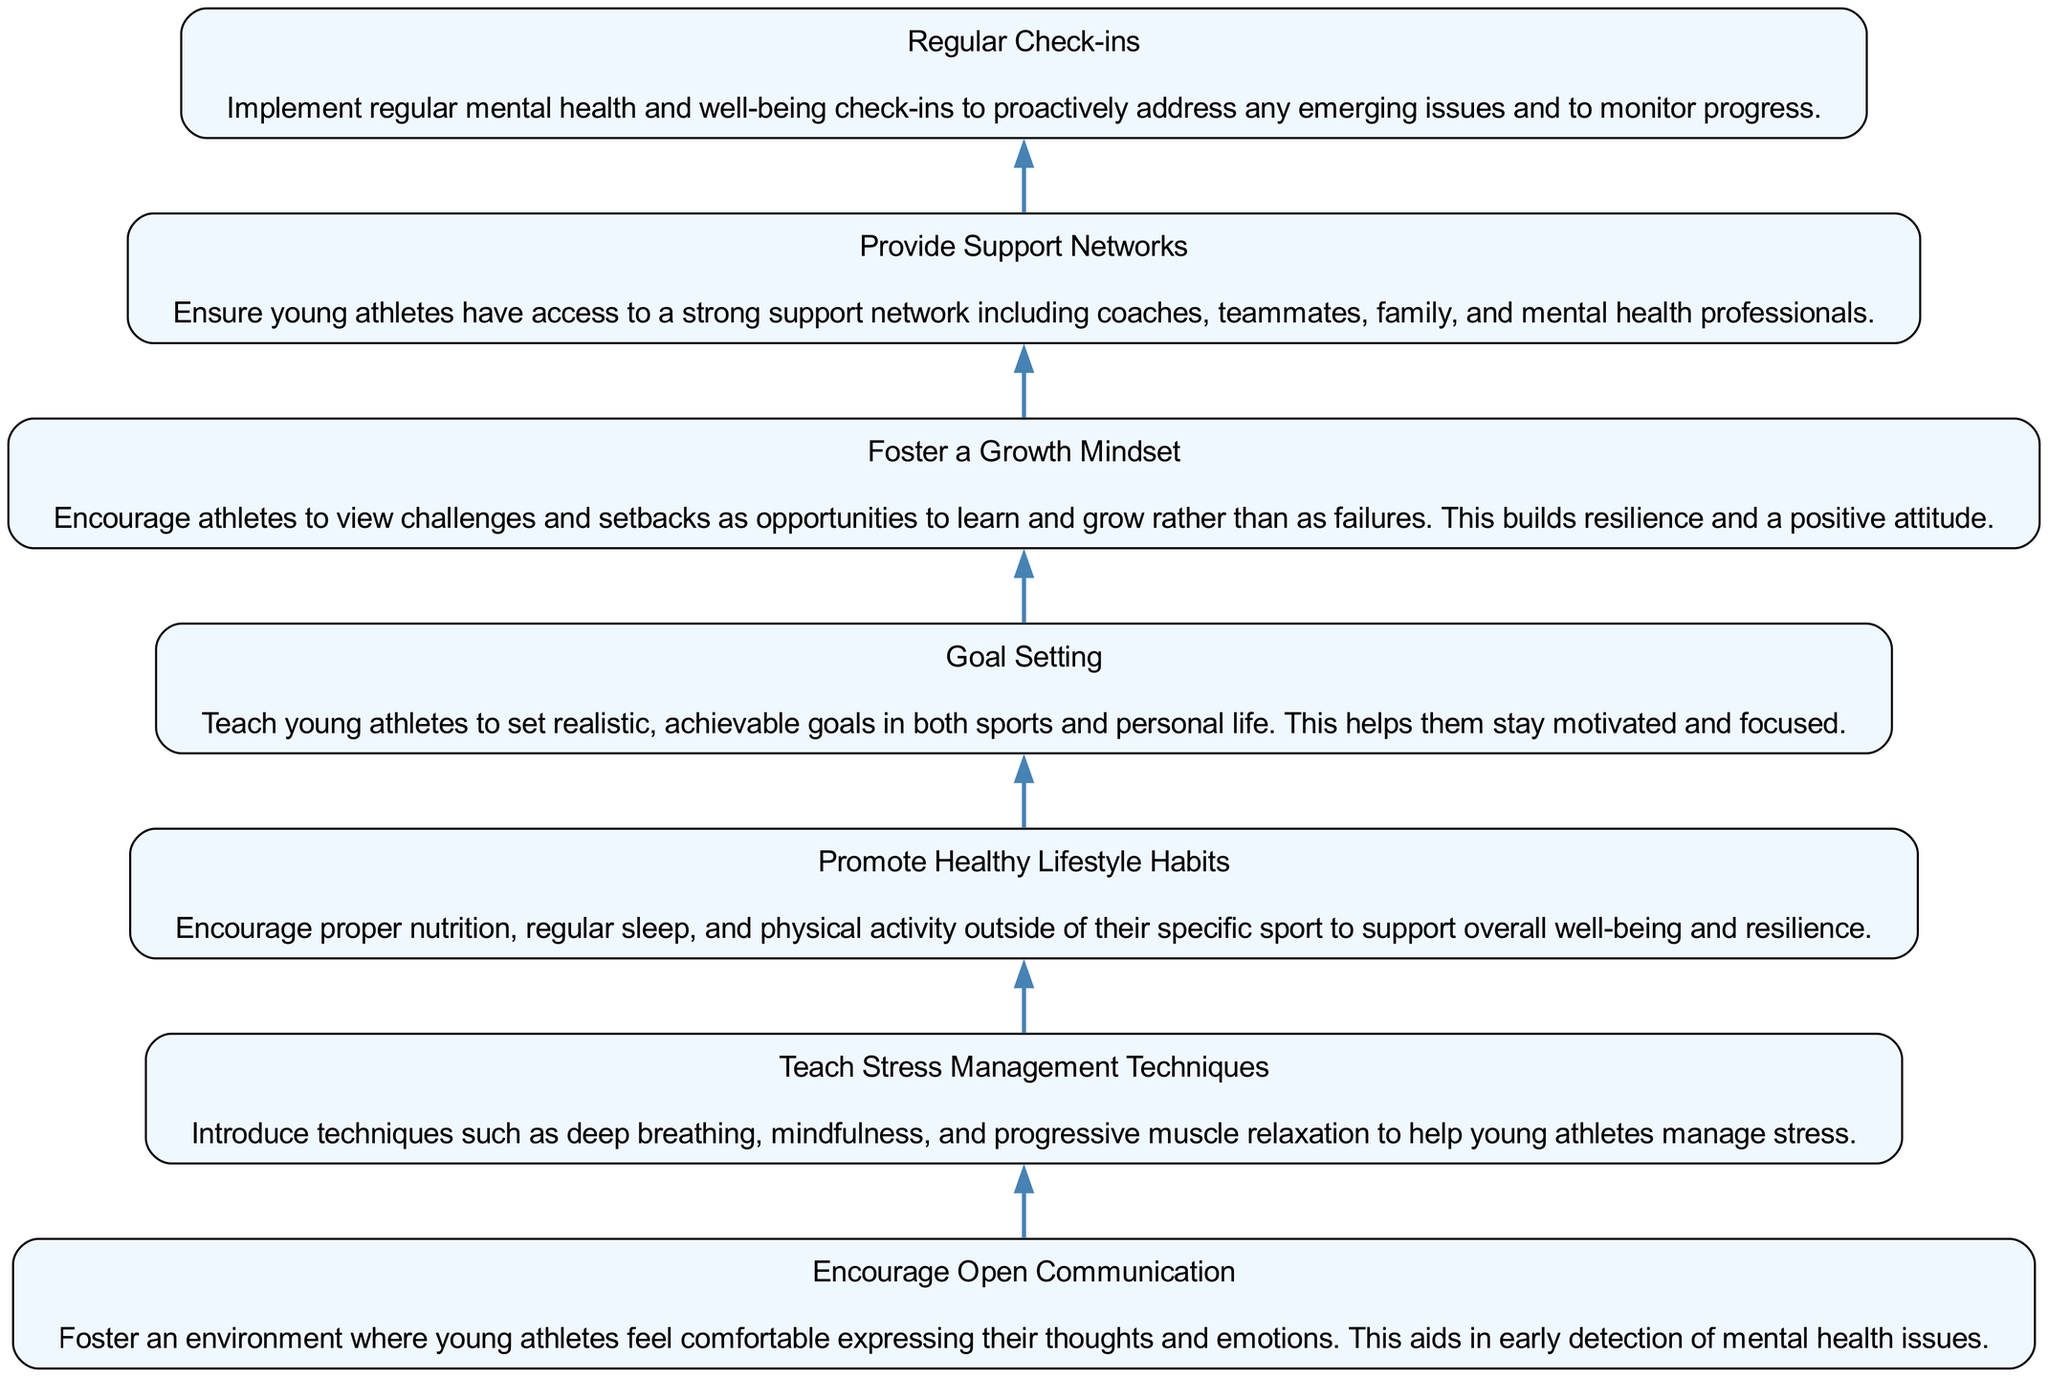What is the first technique listed in the diagram? The first technique at the bottom of the flow chart is "Encourage Open Communication." This can be determined by looking at the order of the nodes from bottom to top.
Answer: Encourage Open Communication How many techniques are outlined in the diagram? By counting all the nodes in the flow chart, there are a total of seven techniques listed. Each node represents one technique, and since the list starts from the bottom and goes to the top, all nodes can be counted easily.
Answer: 7 Which technique emphasizes the importance of nutrition and sleep? The technique that emphasizes the importance of nutrition and sleep is "Promote Healthy Lifestyle Habits." This node specifically mentions proper nutrition, regular sleep, and physical activity as components of a healthy lifestyle.
Answer: Promote Healthy Lifestyle Habits What is the relationship between "Goal Setting" and "Encourage Open Communication"? "Goal Setting" is positioned above "Encourage Open Communication" in the diagram, indicating that it follows in the sequence of techniques. This shows a flow in which fostering open communication precedes the setting of goals in the resilience-building process.
Answer: Goal Setting follows Encourage Open Communication Which technique directly supports the implementation of "Regular Check-ins"? The technique "Provide Support Networks" directly supports "Regular Check-ins." This means that having a strong support network is essential for routinely checking in on mental health and well-being, helping ensure the success of the check-ins.
Answer: Provide Support Networks Which techniques should be prioritized to help establish a mindset that accepts challenges? "Foster a Growth Mindset" should be prioritized to establish a mindset that accepts challenges, as this technique specifically encourages viewing challenges as learning opportunities rather than failures.
Answer: Foster a Growth Mindset How many edges connect the nodes in the diagram? There are six edges connecting the nodes in the diagram, as each technique (except the first one) is linked to the one below it, creating a continuous flow from bottom to top. Each connection represents the relationship of sequence among the techniques, totaling six connections.
Answer: 6 What is the final step in the resilience-building process? The final step in the resilience-building process, as depicted at the top of the flow chart, is "Regular Check-ins." This indicates that consistent follow-ups are crucial after implementing the preceding techniques.
Answer: Regular Check-ins 